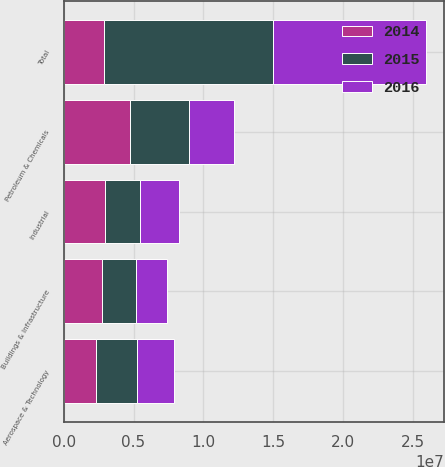Convert chart. <chart><loc_0><loc_0><loc_500><loc_500><stacked_bar_chart><ecel><fcel>Aerospace & Technology<fcel>Buildings & Infrastructure<fcel>Industrial<fcel>Petroleum & Chemicals<fcel>Total<nl><fcel>2016<fcel>2.65743e+06<fcel>2.25351e+06<fcel>2.79371e+06<fcel>3.2595e+06<fcel>1.09642e+07<nl><fcel>2015<fcel>2.92475e+06<fcel>2.45838e+06<fcel>2.51757e+06<fcel>4.21413e+06<fcel>1.21148e+07<nl><fcel>2014<fcel>2.30645e+06<fcel>2.7052e+06<fcel>2.95639e+06<fcel>4.72712e+06<fcel>2.85923e+06<nl></chart> 